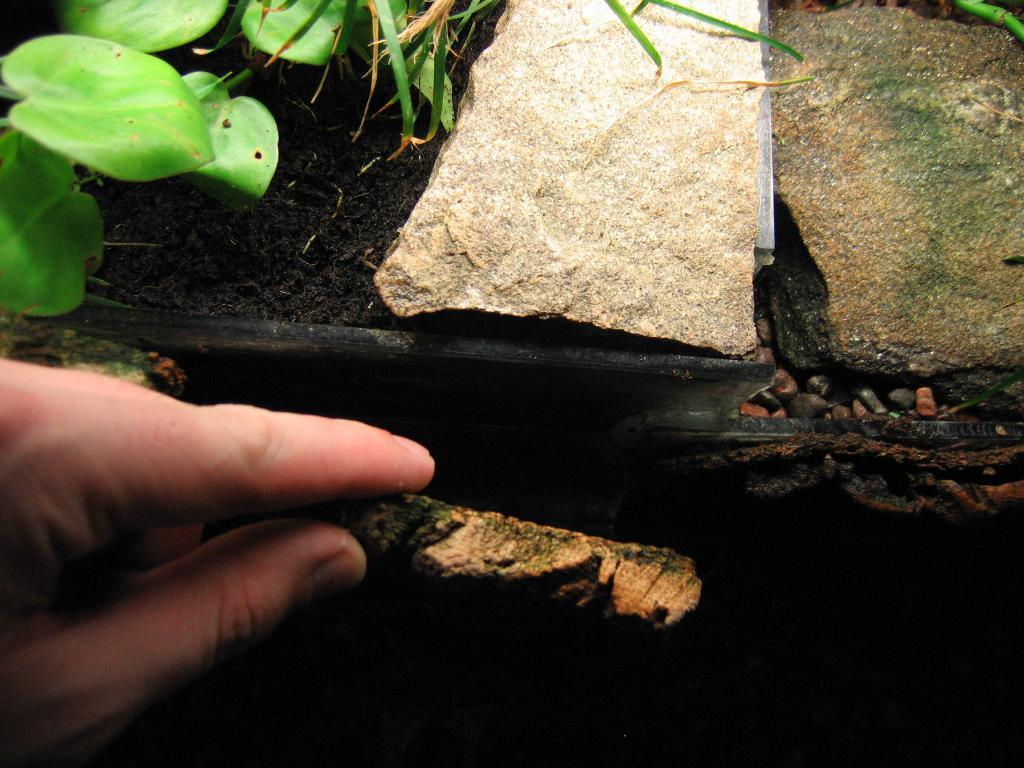What is present in the image? There is a person in the image. What is the person holding? The person is holding an object. What type of natural elements can be seen in the image? There are leaves and stones in the image. What historical discovery was made by the person in the image? There is no indication of a historical discovery in the image; it simply shows a person holding an object and surrounded by leaves and stones. 